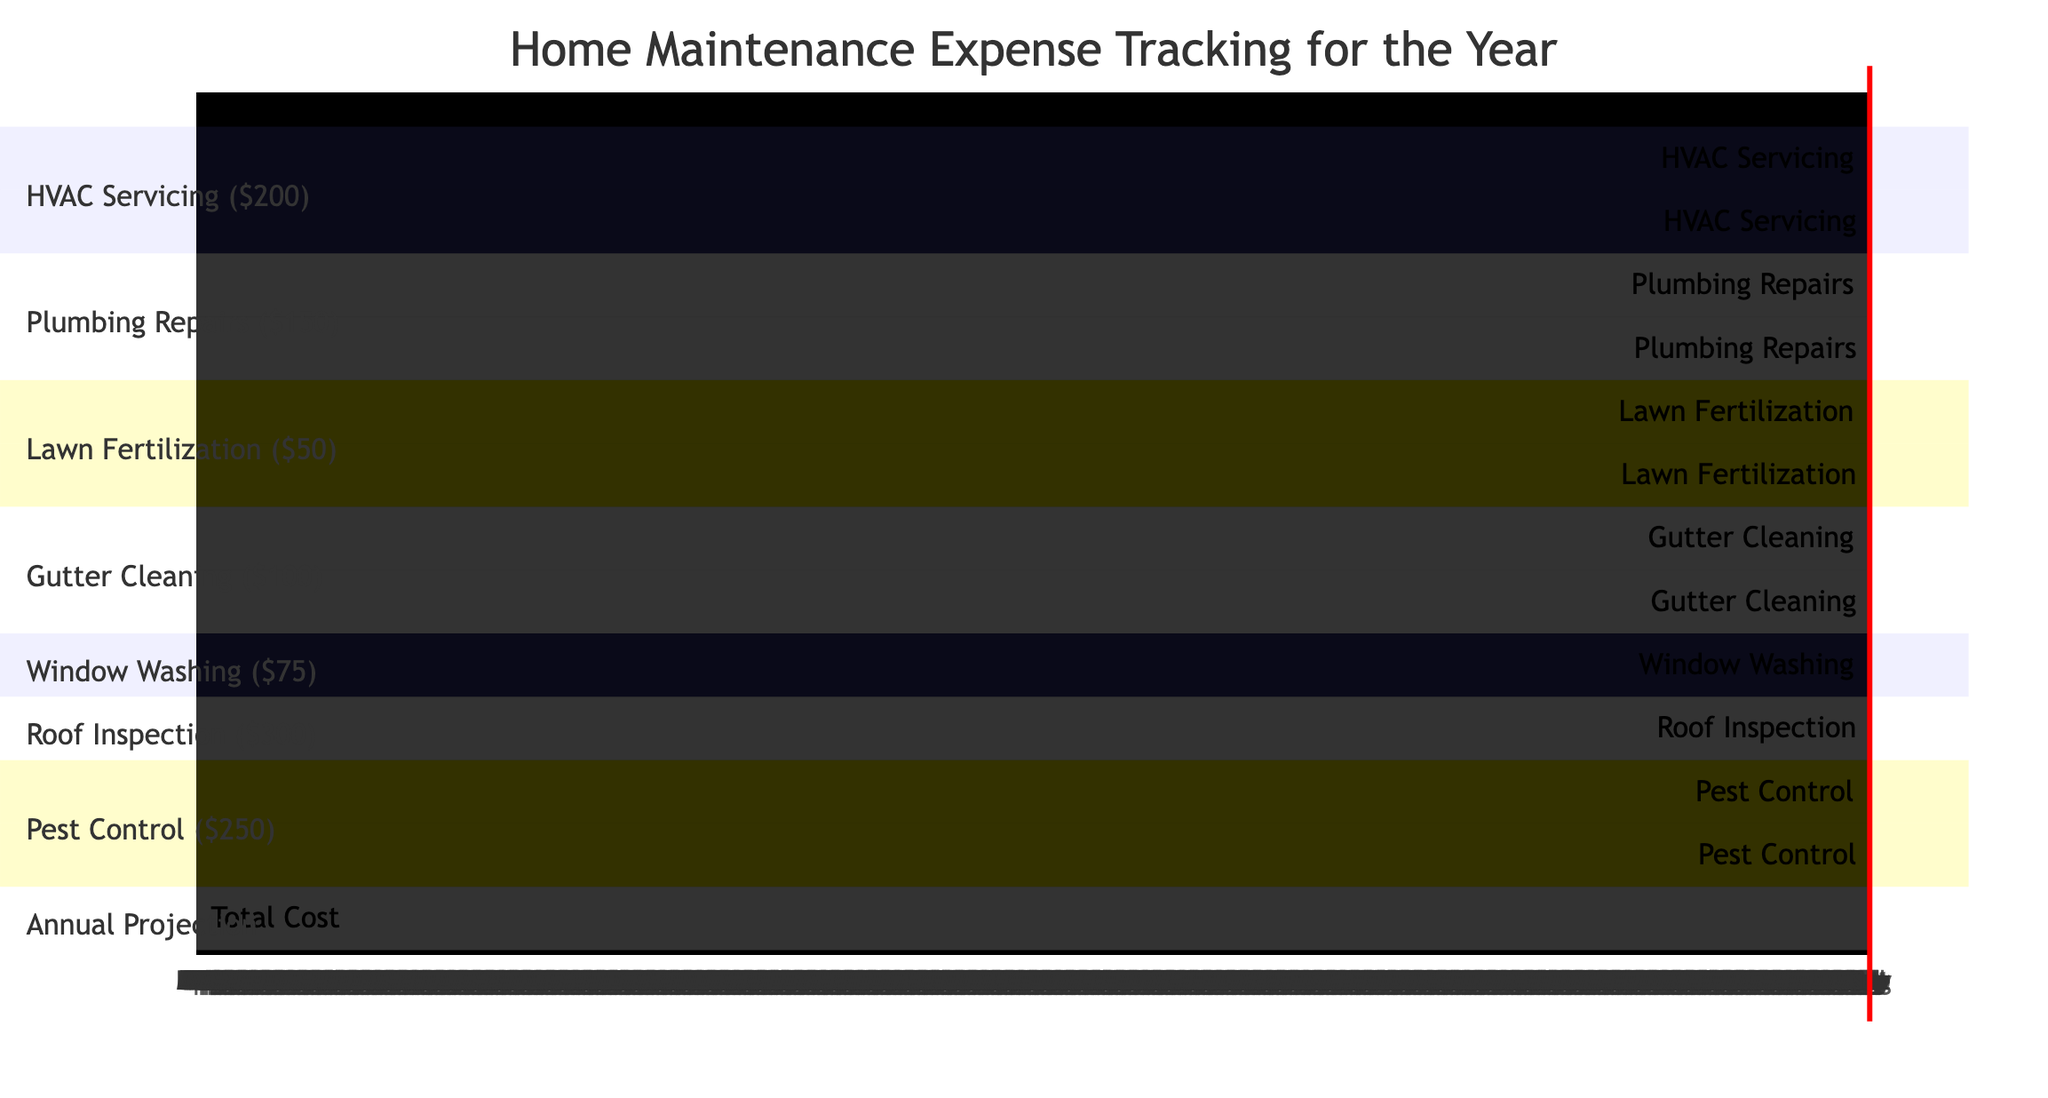What is the total projected cost for home maintenance? The total projected cost is specified in the segment labeled 'Annual Projection' at the end of the diagram. It shows a total cost of $1525.
Answer: $1525 How many times is HVAC servicing planned for the year? By examining the 'HVAC Servicing' section, we can see there are two entries marked for HVAC servicing, which occurs in April and October.
Answer: 2 In which month is the roof inspection scheduled? The 'Roof Inspection' section indicates it is scheduled for September. By looking closely, one can see 'Roof Inspection : 09' on the timeline.
Answer: September What is the cost for plumbing repairs? The cost for plumbing repairs is stated in the section titled 'Plumbing Repairs' alongside the listed maintenance task, which indicates a cost of $150.
Answer: $150 Which maintenance task has the highest individual cost? By reviewing the costs assigned to each maintenance task, 'Roof Inspection' lists the highest cost at $300.
Answer: Roof Inspection In which month are lawn fertilization services planned? There are two occurrences for lawn fertilization indicated, occurring in May and October as shown in the 'Lawn Fertilization' section.
Answer: May, October How many different types of maintenance tasks are scheduled throughout the year? Counting each section in the diagram indicates there are six different types of maintenance tasks listed, including HVAC Servicing, Plumbing Repairs, Lawn Fertilization, Gutter Cleaning, Window Washing, Roof Inspection, and Pest Control.
Answer: 7 What is the total number of tasks scheduled for April? By looking at the timeline, we can see there are three maintenance tasks scheduled for April: HVAC Servicing, Pest Control, and Lawn Fertilization.
Answer: 3 Which service is scheduled most frequently? The analysis of the number of times each service is scheduled indicates ‘Lawn Fertilization’ occurs twice, as does ‘HVAC Servicing’ and ‘Pest Control’; however, they all have the same frequency.
Answer: Lawn Fertilization, HVAC Servicing, Pest Control 